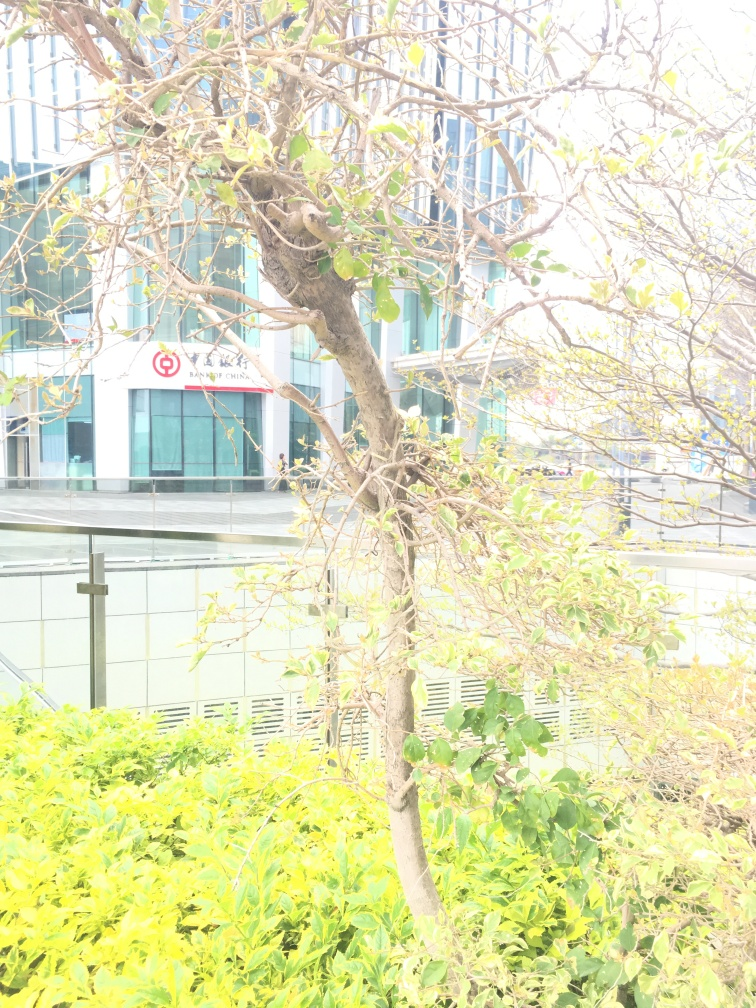What happened to the texture details of the green plants? The texture details of the green plants in the image have been lost to an extent, likely due to the overexposure in the photograph. This overexposure results in areas of the image where detail is washed out, making the leaves and branches appear less defined. While some outlines of leaves and branches remain visible, the nuances of their textures are not distinctly perceived. 